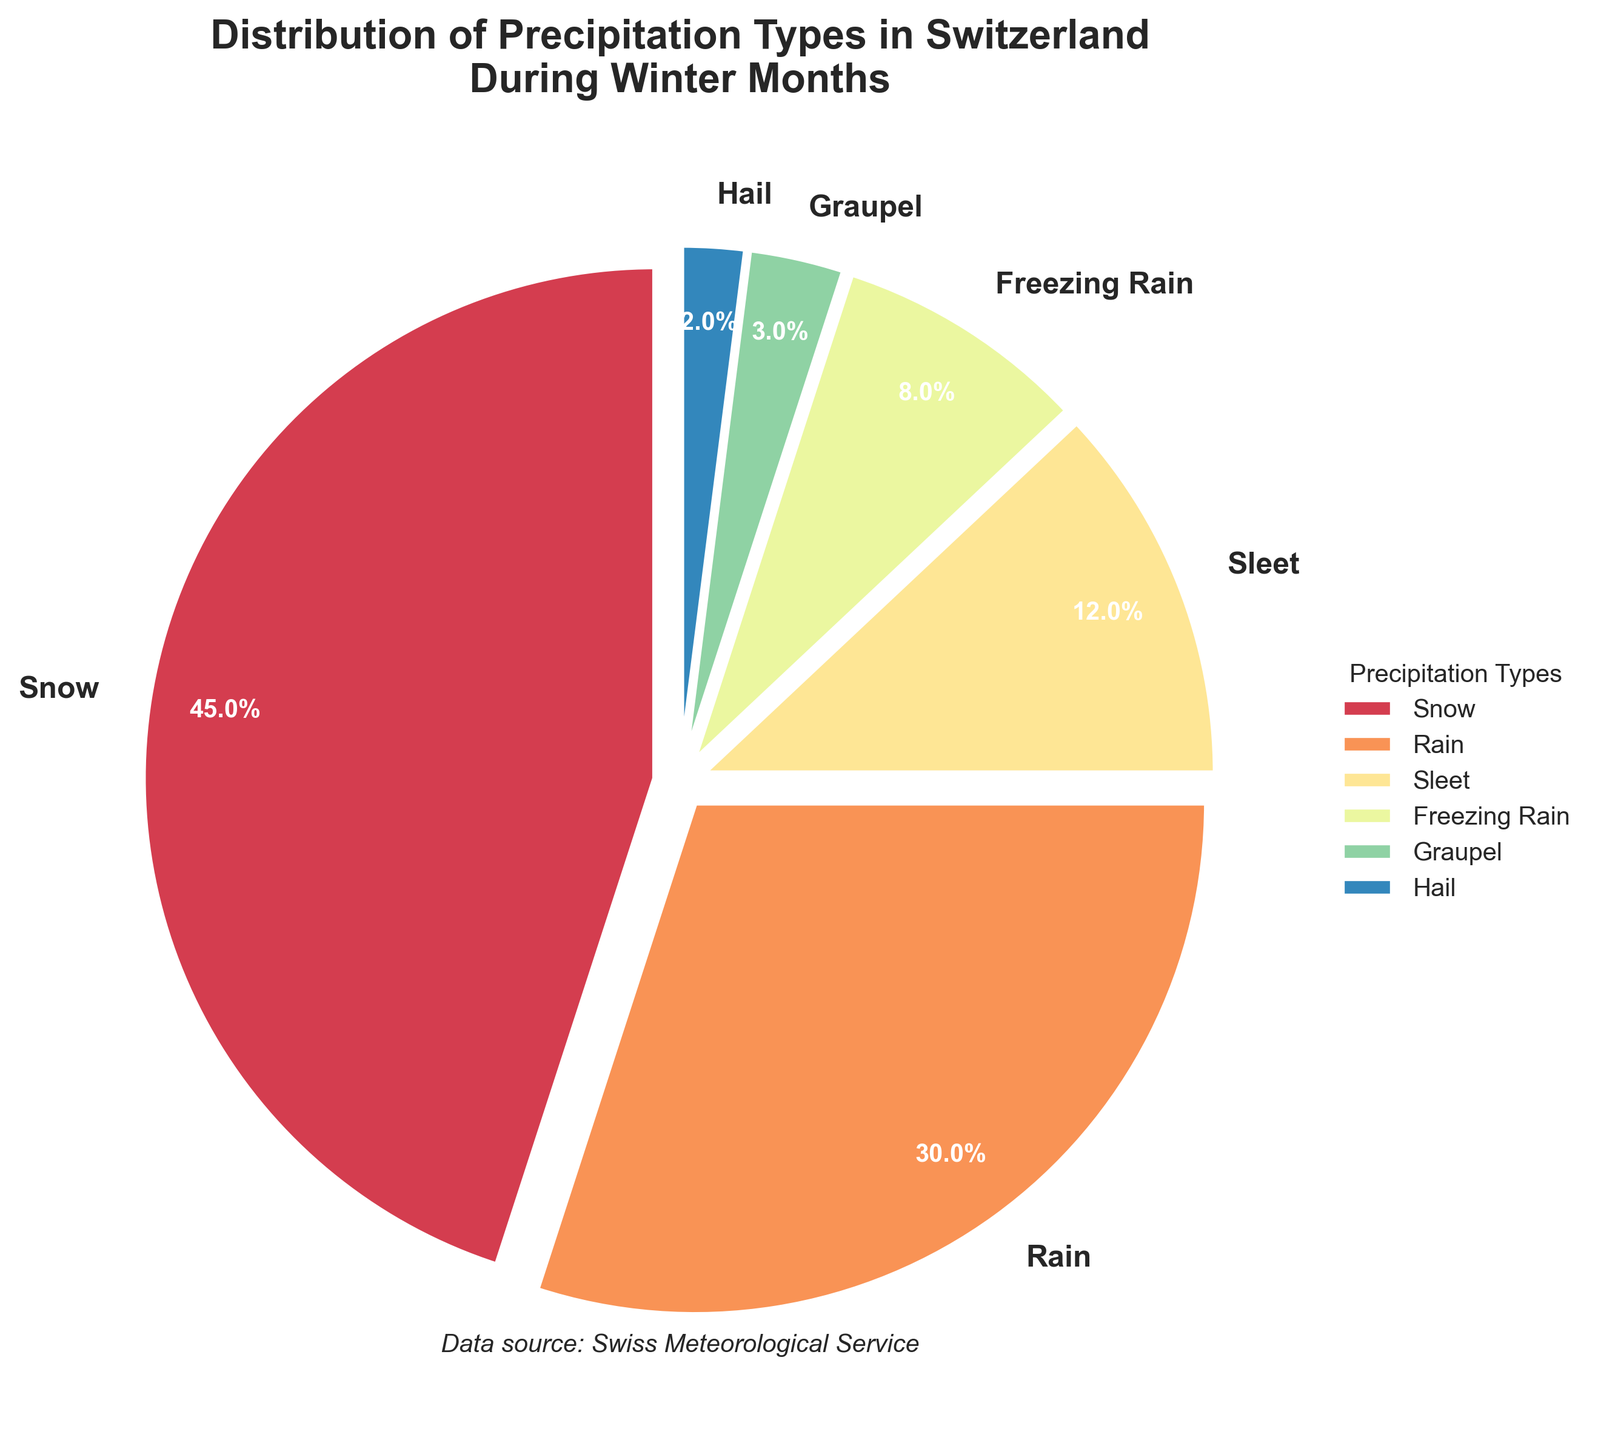What type of precipitation is the most common during winter in Switzerland? The most common precipitation is the section with the largest percentage in the pie chart. By looking at the figure, snow clearly occupies the largest portion.
Answer: Snow Which type of precipitation is more frequent, freezing rain or graupel? To determine which type is more frequent, compare the sizes of the wedges for freezing rain and graupel. Freezing rain has 8%, and graupel has 3%.
Answer: Freezing rain What is the combined percentage of rain and sleet? Add the percentages of rain and sleet. Rain represents 30%, and sleet represents 12%, so the combined percentage is 30% + 12% = 42%.
Answer: 42% What is the difference in percentage between the most common and the second most common types of precipitation? The most common type is snow with 45%, and the second most common is rain with 30%. The difference is 45% - 30% = 15%.
Answer: 15% How does the percentage of sleet compare to hail? Compare the percentages of sleet and hail. Sleet has 12%, while hail has 2%. Sleet is significantly more frequent than hail.
Answer: Sleet is more frequent What percentage of precipitation types other than snow fall in winter? Subtract the percentage of snow from the total (100%). Snow has 45%, so 100% - 45% = 55%.
Answer: 55% Which types of precipitation together make up nearly the same percentage as snow alone? Identify types whose combined percentages approximate snow's 45%. Rain (30%) and sleet (12%) together add to 42%, which is close to 45%.
Answer: Rain and sleet What visual features help to differentiate the wedges in the pie chart? The wedges are differentiated by various colors and exploded slices, with each slice slightly separated from the rest. Additionally, the labels and percentage values aid in differentiating them.
Answer: Colors and separation Is the percentage of hail higher or lower than the percentage of graupel? Compare the percentages of hail and graupel. Hail is 2%, and graupel is 3%. Hail is lower.
Answer: Lower What is the total percentage for the three least common precipitation types? Add the percentages of the three least common types: sleet (12%), graupel (3%), and hail (2%), for a total of 12% + 3% + 2% = 17%.
Answer: 17% 